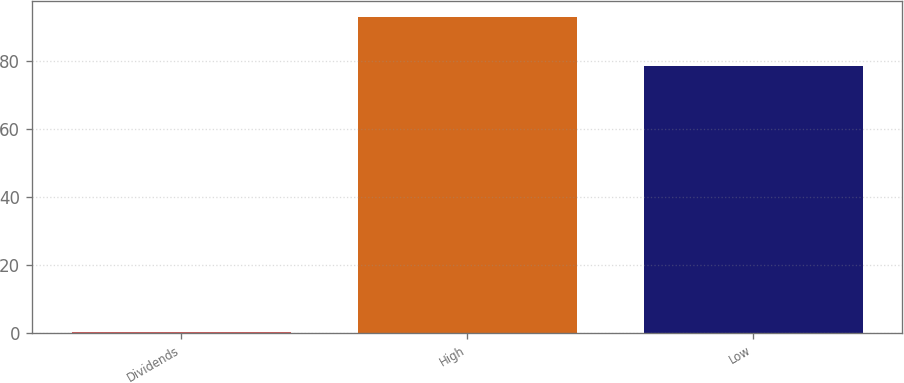Convert chart. <chart><loc_0><loc_0><loc_500><loc_500><bar_chart><fcel>Dividends<fcel>High<fcel>Low<nl><fcel>0.3<fcel>92.96<fcel>78.65<nl></chart> 